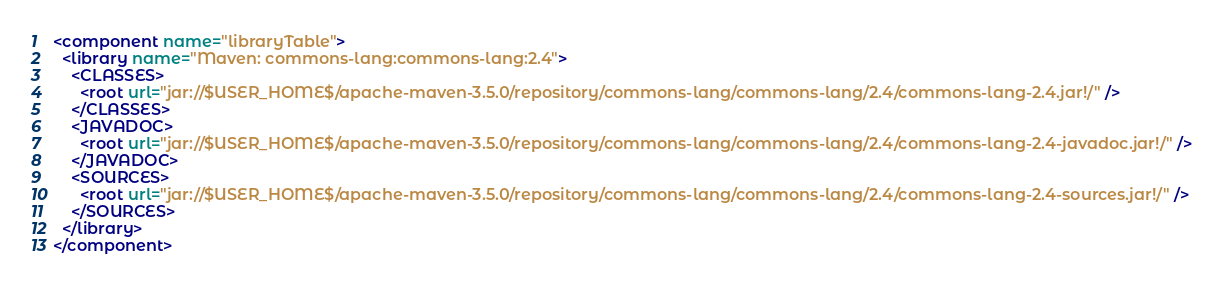Convert code to text. <code><loc_0><loc_0><loc_500><loc_500><_XML_><component name="libraryTable">
  <library name="Maven: commons-lang:commons-lang:2.4">
    <CLASSES>
      <root url="jar://$USER_HOME$/apache-maven-3.5.0/repository/commons-lang/commons-lang/2.4/commons-lang-2.4.jar!/" />
    </CLASSES>
    <JAVADOC>
      <root url="jar://$USER_HOME$/apache-maven-3.5.0/repository/commons-lang/commons-lang/2.4/commons-lang-2.4-javadoc.jar!/" />
    </JAVADOC>
    <SOURCES>
      <root url="jar://$USER_HOME$/apache-maven-3.5.0/repository/commons-lang/commons-lang/2.4/commons-lang-2.4-sources.jar!/" />
    </SOURCES>
  </library>
</component></code> 